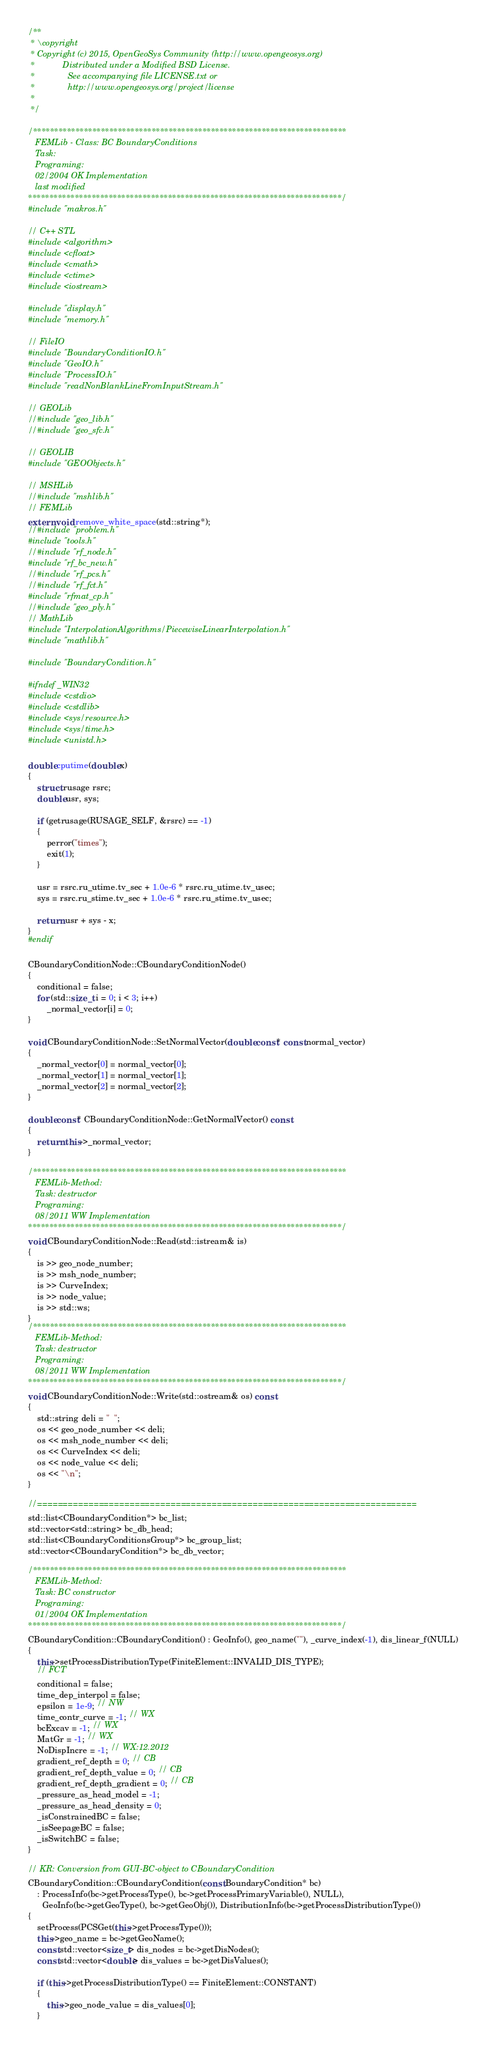Convert code to text. <code><loc_0><loc_0><loc_500><loc_500><_C++_>/**
 * \copyright
 * Copyright (c) 2015, OpenGeoSys Community (http://www.opengeosys.org)
 *            Distributed under a Modified BSD License.
 *              See accompanying file LICENSE.txt or
 *              http://www.opengeosys.org/project/license
 *
 */

/**************************************************************************
   FEMLib - Class: BC BoundaryConditions
   Task:
   Programing:
   02/2004 OK Implementation
   last modified
**************************************************************************/
#include "makros.h"

// C++ STL
#include <algorithm>
#include <cfloat>
#include <cmath>
#include <ctime>
#include <iostream>

#include "display.h"
#include "memory.h"

// FileIO
#include "BoundaryConditionIO.h"
#include "GeoIO.h"
#include "ProcessIO.h"
#include "readNonBlankLineFromInputStream.h"

// GEOLib
//#include "geo_lib.h"
//#include "geo_sfc.h"

// GEOLIB
#include "GEOObjects.h"

// MSHLib
//#include "mshlib.h"
// FEMLib
extern void remove_white_space(std::string*);
//#include "problem.h"
#include "tools.h"
//#include "rf_node.h"
#include "rf_bc_new.h"
//#include "rf_pcs.h"
//#include "rf_fct.h"
#include "rfmat_cp.h"
//#include "geo_ply.h"
// MathLib
#include "InterpolationAlgorithms/PiecewiseLinearInterpolation.h"
#include "mathlib.h"

#include "BoundaryCondition.h"

#ifndef _WIN32
#include <cstdio>
#include <cstdlib>
#include <sys/resource.h>
#include <sys/time.h>
#include <unistd.h>

double cputime(double x)
{
	struct rusage rsrc;
	double usr, sys;

	if (getrusage(RUSAGE_SELF, &rsrc) == -1)
	{
		perror("times");
		exit(1);
	}

	usr = rsrc.ru_utime.tv_sec + 1.0e-6 * rsrc.ru_utime.tv_usec;
	sys = rsrc.ru_stime.tv_sec + 1.0e-6 * rsrc.ru_stime.tv_usec;

	return usr + sys - x;
}
#endif

CBoundaryConditionNode::CBoundaryConditionNode()
{
	conditional = false;
	for (std::size_t i = 0; i < 3; i++)
		_normal_vector[i] = 0;
}

void CBoundaryConditionNode::SetNormalVector(double const* const normal_vector)
{
	_normal_vector[0] = normal_vector[0];
	_normal_vector[1] = normal_vector[1];
	_normal_vector[2] = normal_vector[2];
}

double const* CBoundaryConditionNode::GetNormalVector() const
{
	return this->_normal_vector;
}

/**************************************************************************
   FEMLib-Method:
   Task: destructor
   Programing:
   08/2011 WW Implementation
**************************************************************************/
void CBoundaryConditionNode::Read(std::istream& is)
{
	is >> geo_node_number;
	is >> msh_node_number;
	is >> CurveIndex;
	is >> node_value;
	is >> std::ws;
}
/**************************************************************************
   FEMLib-Method:
   Task: destructor
   Programing:
   08/2011 WW Implementation
**************************************************************************/
void CBoundaryConditionNode::Write(std::ostream& os) const
{
	std::string deli = "  ";
	os << geo_node_number << deli;
	os << msh_node_number << deli;
	os << CurveIndex << deli;
	os << node_value << deli;
	os << "\n";
}

//==========================================================================
std::list<CBoundaryCondition*> bc_list;
std::vector<std::string> bc_db_head;
std::list<CBoundaryConditionsGroup*> bc_group_list;
std::vector<CBoundaryCondition*> bc_db_vector;

/**************************************************************************
   FEMLib-Method:
   Task: BC constructor
   Programing:
   01/2004 OK Implementation
**************************************************************************/
CBoundaryCondition::CBoundaryCondition() : GeoInfo(), geo_name(""), _curve_index(-1), dis_linear_f(NULL)
{
	this->setProcessDistributionType(FiniteElement::INVALID_DIS_TYPE);
	// FCT
	conditional = false;
	time_dep_interpol = false;
	epsilon = 1e-9; // NW
	time_contr_curve = -1; // WX
	bcExcav = -1; // WX
	MatGr = -1; // WX
	NoDispIncre = -1; // WX:12.2012
	gradient_ref_depth = 0; // CB
	gradient_ref_depth_value = 0; // CB
	gradient_ref_depth_gradient = 0; // CB
	_pressure_as_head_model = -1;
	_pressure_as_head_density = 0;
	_isConstrainedBC = false;
	_isSeepageBC = false;
	_isSwitchBC = false;
}

// KR: Conversion from GUI-BC-object to CBoundaryCondition
CBoundaryCondition::CBoundaryCondition(const BoundaryCondition* bc)
    : ProcessInfo(bc->getProcessType(), bc->getProcessPrimaryVariable(), NULL),
      GeoInfo(bc->getGeoType(), bc->getGeoObj()), DistributionInfo(bc->getProcessDistributionType())
{
	setProcess(PCSGet(this->getProcessType()));
	this->geo_name = bc->getGeoName();
	const std::vector<size_t> dis_nodes = bc->getDisNodes();
	const std::vector<double> dis_values = bc->getDisValues();

	if (this->getProcessDistributionType() == FiniteElement::CONSTANT)
	{
		this->geo_node_value = dis_values[0];
	}</code> 